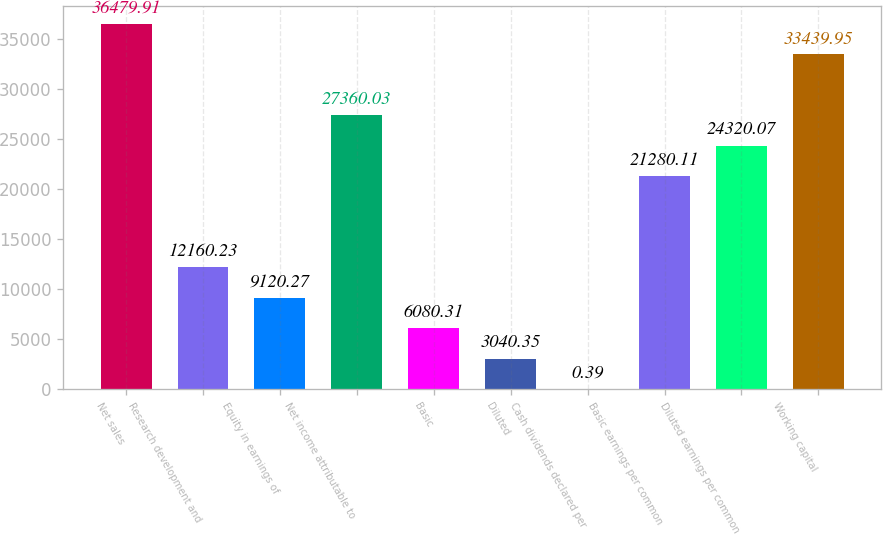Convert chart. <chart><loc_0><loc_0><loc_500><loc_500><bar_chart><fcel>Net sales<fcel>Research development and<fcel>Equity in earnings of<fcel>Net income attributable to<fcel>Basic<fcel>Diluted<fcel>Cash dividends declared per<fcel>Basic earnings per common<fcel>Diluted earnings per common<fcel>Working capital<nl><fcel>36479.9<fcel>12160.2<fcel>9120.27<fcel>27360<fcel>6080.31<fcel>3040.35<fcel>0.39<fcel>21280.1<fcel>24320.1<fcel>33439.9<nl></chart> 